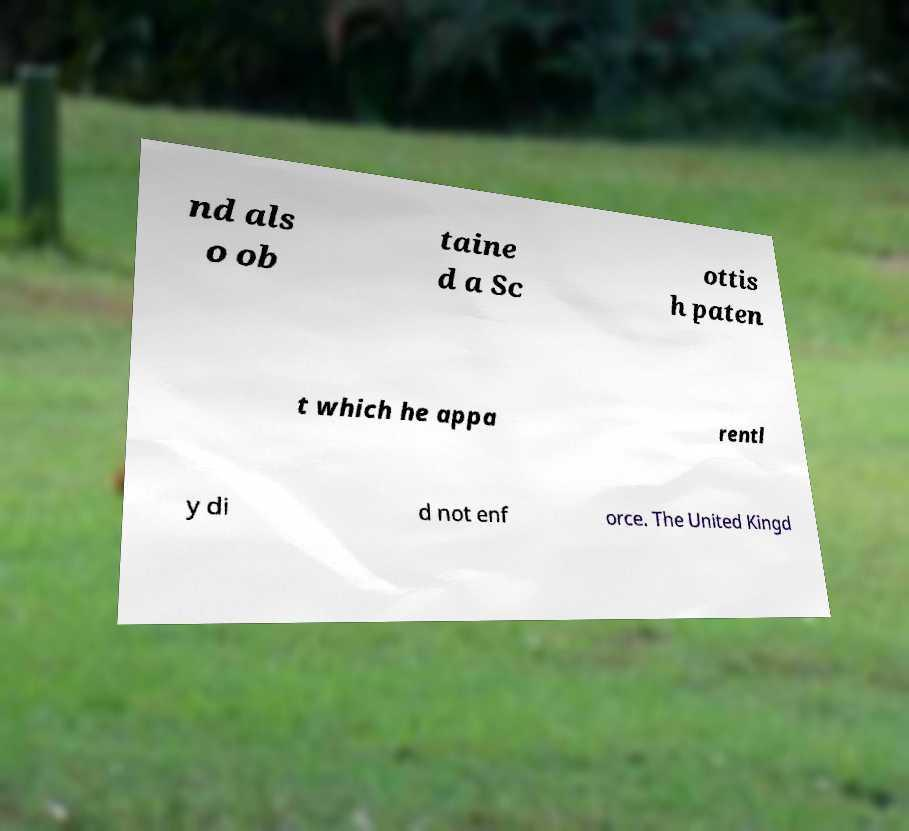Could you assist in decoding the text presented in this image and type it out clearly? nd als o ob taine d a Sc ottis h paten t which he appa rentl y di d not enf orce. The United Kingd 